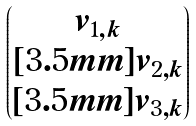<formula> <loc_0><loc_0><loc_500><loc_500>\begin{pmatrix} v _ { 1 , k } \\ [ 3 . 5 m m ] v _ { 2 , k } \\ [ 3 . 5 m m ] v _ { 3 , k } \end{pmatrix}</formula> 